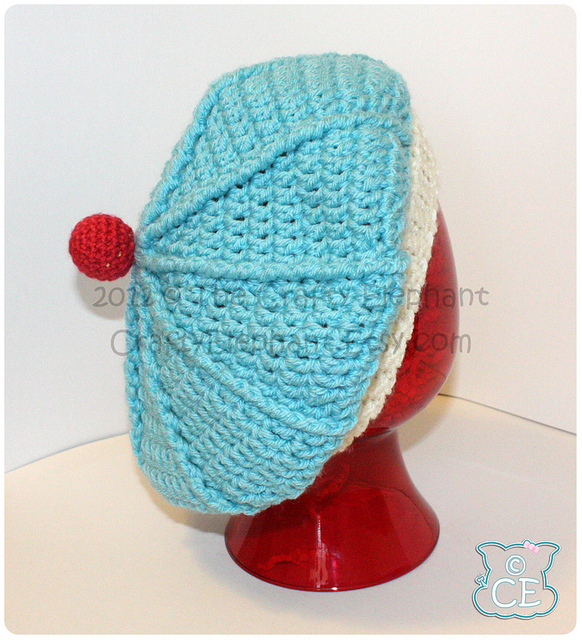Identify the text contained in this image. Craft Eesy.com 2012 CE 